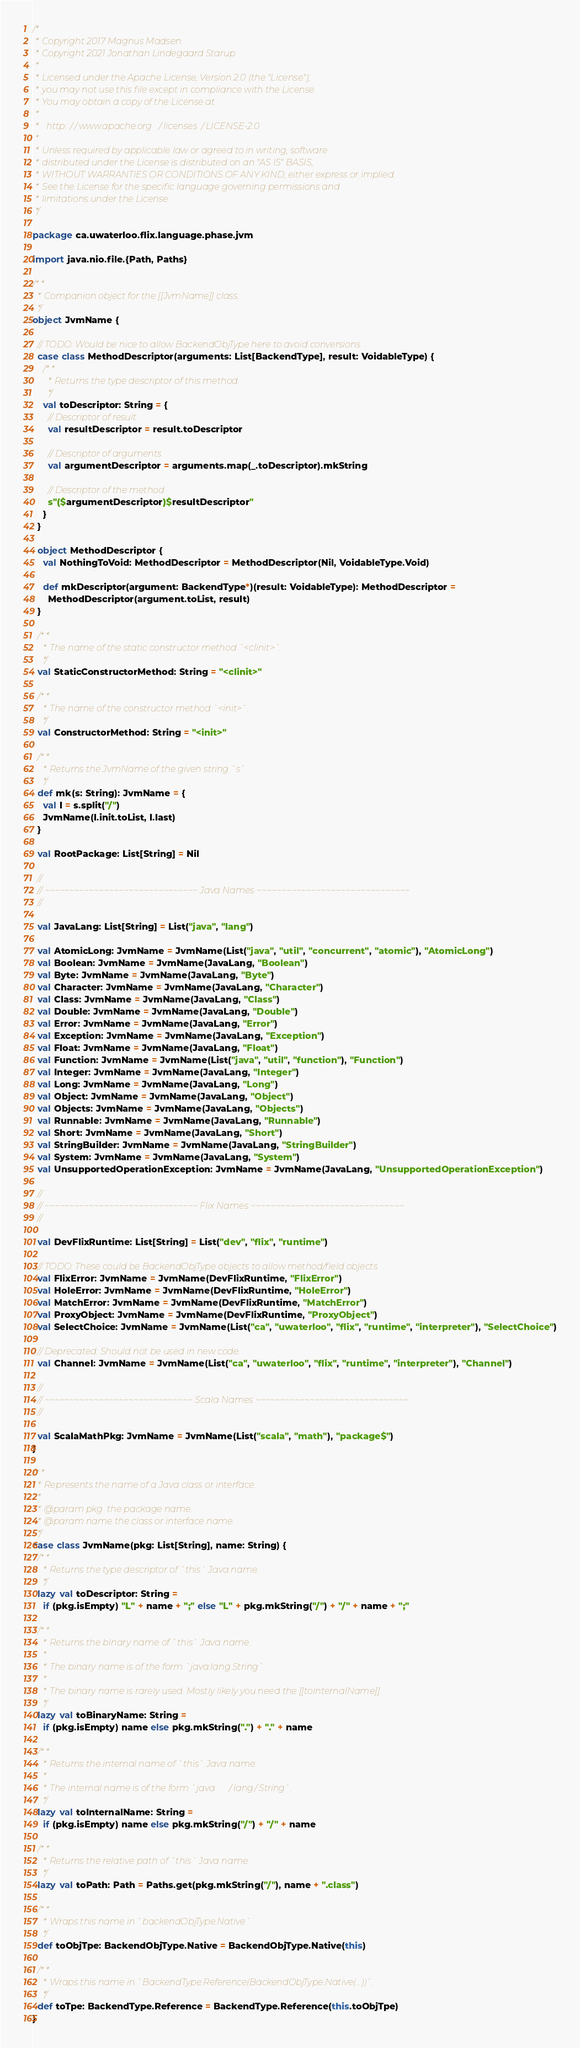Convert code to text. <code><loc_0><loc_0><loc_500><loc_500><_Scala_>/*
 * Copyright 2017 Magnus Madsen
 * Copyright 2021 Jonathan Lindegaard Starup
 *
 * Licensed under the Apache License, Version 2.0 (the "License");
 * you may not use this file except in compliance with the License.
 * You may obtain a copy of the License at
 *
 *   http://www.apache.org/licenses/LICENSE-2.0
 *
 * Unless required by applicable law or agreed to in writing, software
 * distributed under the License is distributed on an "AS IS" BASIS,
 * WITHOUT WARRANTIES OR CONDITIONS OF ANY KIND, either express or implied.
 * See the License for the specific language governing permissions and
 * limitations under the License.
 */

package ca.uwaterloo.flix.language.phase.jvm

import java.nio.file.{Path, Paths}

/**
  * Companion object for the [[JvmName]] class.
  */
object JvmName {

  // TODO: Would be nice to allow BackendObjType here to avoid conversions
  case class MethodDescriptor(arguments: List[BackendType], result: VoidableType) {
    /**
      * Returns the type descriptor of this method.
      */
    val toDescriptor: String = {
      // Descriptor of result
      val resultDescriptor = result.toDescriptor

      // Descriptor of arguments
      val argumentDescriptor = arguments.map(_.toDescriptor).mkString

      // Descriptor of the method
      s"($argumentDescriptor)$resultDescriptor"
    }
  }

  object MethodDescriptor {
    val NothingToVoid: MethodDescriptor = MethodDescriptor(Nil, VoidableType.Void)

    def mkDescriptor(argument: BackendType*)(result: VoidableType): MethodDescriptor =
      MethodDescriptor(argument.toList, result)
  }

  /**
    * The name of the static constructor method `<clinit>`.
    */
  val StaticConstructorMethod: String = "<clinit>"

  /**
    * The name of the constructor method `<init>`.
    */
  val ConstructorMethod: String = "<init>"

  /**
    * Returns the JvmName of the given string `s`.
    */
  def mk(s: String): JvmName = {
    val l = s.split("/")
    JvmName(l.init.toList, l.last)
  }

  val RootPackage: List[String] = Nil

  //
  // ~~~~~~~~~~~~~~~~~~~~~~~~~~~~~~~ Java Names ~~~~~~~~~~~~~~~~~~~~~~~~~~~~~~~
  //

  val JavaLang: List[String] = List("java", "lang")

  val AtomicLong: JvmName = JvmName(List("java", "util", "concurrent", "atomic"), "AtomicLong")
  val Boolean: JvmName = JvmName(JavaLang, "Boolean")
  val Byte: JvmName = JvmName(JavaLang, "Byte")
  val Character: JvmName = JvmName(JavaLang, "Character")
  val Class: JvmName = JvmName(JavaLang, "Class")
  val Double: JvmName = JvmName(JavaLang, "Double")
  val Error: JvmName = JvmName(JavaLang, "Error")
  val Exception: JvmName = JvmName(JavaLang, "Exception")
  val Float: JvmName = JvmName(JavaLang, "Float")
  val Function: JvmName = JvmName(List("java", "util", "function"), "Function")
  val Integer: JvmName = JvmName(JavaLang, "Integer")
  val Long: JvmName = JvmName(JavaLang, "Long")
  val Object: JvmName = JvmName(JavaLang, "Object")
  val Objects: JvmName = JvmName(JavaLang, "Objects")
  val Runnable: JvmName = JvmName(JavaLang, "Runnable")
  val Short: JvmName = JvmName(JavaLang, "Short")
  val StringBuilder: JvmName = JvmName(JavaLang, "StringBuilder")
  val System: JvmName = JvmName(JavaLang, "System")
  val UnsupportedOperationException: JvmName = JvmName(JavaLang, "UnsupportedOperationException")

  //
  // ~~~~~~~~~~~~~~~~~~~~~~~~~~~~~~~ Flix Names ~~~~~~~~~~~~~~~~~~~~~~~~~~~~~~~
  //

  val DevFlixRuntime: List[String] = List("dev", "flix", "runtime")

  // TODO: These could be BackendObjType objects to allow method/field objects
  val FlixError: JvmName = JvmName(DevFlixRuntime, "FlixError")
  val HoleError: JvmName = JvmName(DevFlixRuntime, "HoleError")
  val MatchError: JvmName = JvmName(DevFlixRuntime, "MatchError")
  val ProxyObject: JvmName = JvmName(DevFlixRuntime, "ProxyObject")
  val SelectChoice: JvmName = JvmName(List("ca", "uwaterloo", "flix", "runtime", "interpreter"), "SelectChoice")

  // Deprecated: Should not be used in new code.
  val Channel: JvmName = JvmName(List("ca", "uwaterloo", "flix", "runtime", "interpreter"), "Channel")

  //
  // ~~~~~~~~~~~~~~~~~~~~~~~~~~~~~~ Scala Names ~~~~~~~~~~~~~~~~~~~~~~~~~~~~~~~
  //

  val ScalaMathPkg: JvmName = JvmName(List("scala", "math"), "package$")
}

/**
  * Represents the name of a Java class or interface.
  *
  * @param pkg  the package name.
  * @param name the class or interface name.
  */
case class JvmName(pkg: List[String], name: String) {
  /**
    * Returns the type descriptor of `this` Java name.
    */
  lazy val toDescriptor: String =
    if (pkg.isEmpty) "L" + name + ";" else "L" + pkg.mkString("/") + "/" + name + ";"

  /**
    * Returns the binary name of `this` Java name.
    *
    * The binary name is of the form `java.lang.String`.
    *
    * The binary name is rarely used. Mostly likely you need the [[toInternalName]].
    */
  lazy val toBinaryName: String =
    if (pkg.isEmpty) name else pkg.mkString(".") + "." + name

  /**
    * Returns the internal name of `this` Java name.
    *
    * The internal name is of the form `java/lang/String`.
    */
  lazy val toInternalName: String =
    if (pkg.isEmpty) name else pkg.mkString("/") + "/" + name

  /**
    * Returns the relative path of `this` Java name.
    */
  lazy val toPath: Path = Paths.get(pkg.mkString("/"), name + ".class")

  /**
    * Wraps this name in `backendObjType.Native`.
    */
  def toObjTpe: BackendObjType.Native = BackendObjType.Native(this)

  /**
    * Wraps this name in `BackendType.Reference(BackendObjType.Native(...))`.
    */
  def toTpe: BackendType.Reference = BackendType.Reference(this.toObjTpe)
}
</code> 